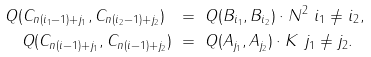<formula> <loc_0><loc_0><loc_500><loc_500>Q ( C _ { n ( i _ { 1 } - 1 ) + j _ { 1 } } , C _ { n ( i _ { 2 } - 1 ) + j _ { 2 } } ) \ & = \ Q ( B _ { i _ { 1 } } , B _ { i _ { 2 } } ) \cdot N ^ { 2 } \ i _ { 1 } \not = i _ { 2 } , \\ Q ( C _ { n ( i - 1 ) + j _ { 1 } } , C _ { n ( i - 1 ) + j _ { 2 } } ) \ & = \ Q ( A _ { j _ { 1 } } , A _ { j _ { 2 } } ) \cdot K \ j _ { 1 } \not = j _ { 2 } .</formula> 